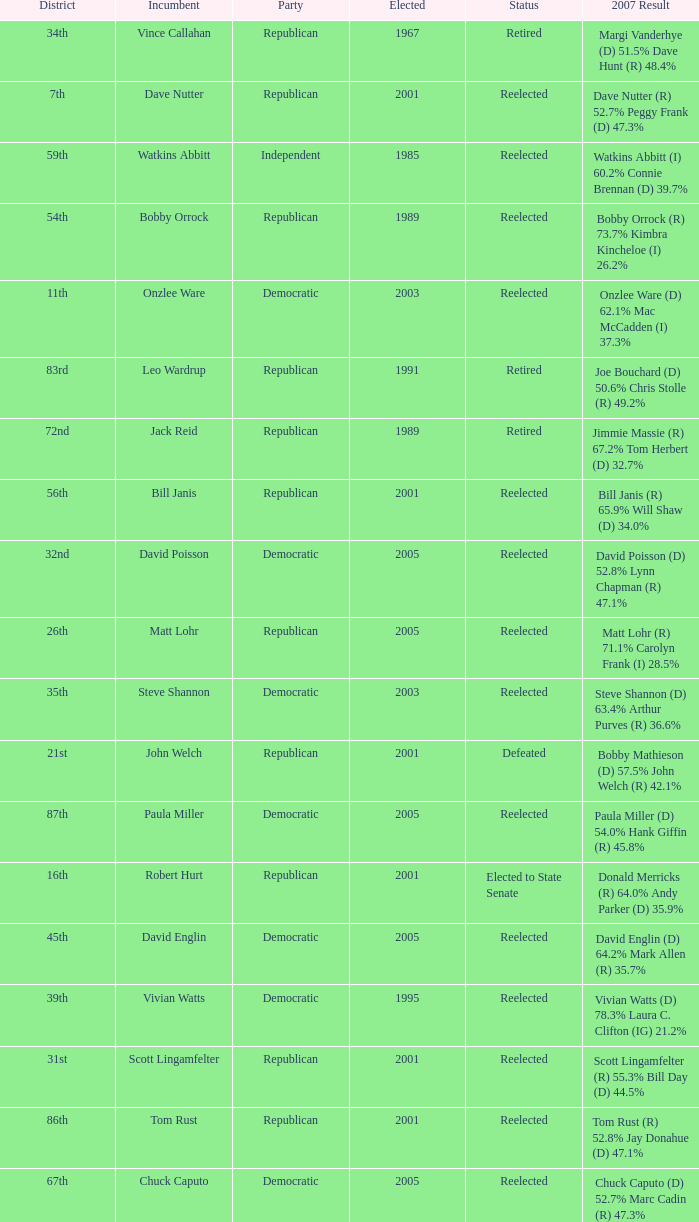What district is incument terry kilgore from? 1st. 